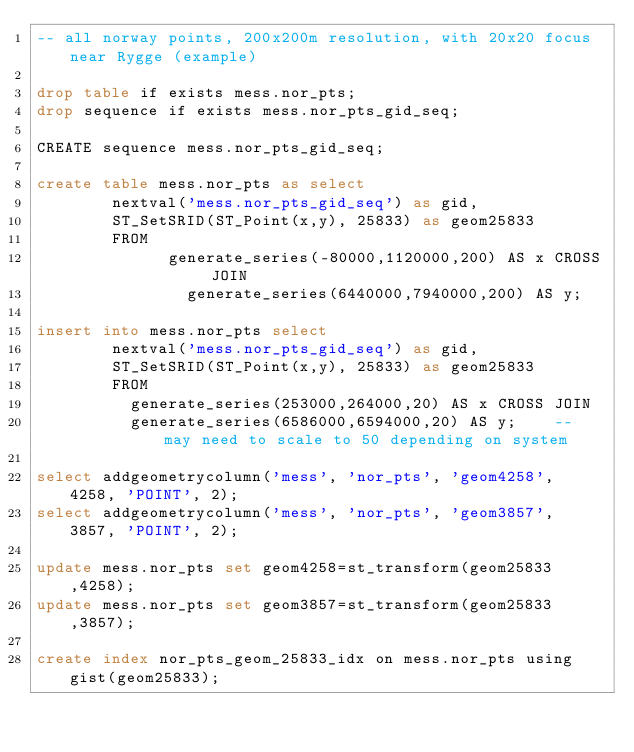<code> <loc_0><loc_0><loc_500><loc_500><_SQL_>-- all norway points, 200x200m resolution, with 20x20 focus near Rygge (example)

drop table if exists mess.nor_pts;
drop sequence if exists mess.nor_pts_gid_seq;

CREATE sequence mess.nor_pts_gid_seq;

create table mess.nor_pts as select 
        nextval('mess.nor_pts_gid_seq') as gid,
        ST_SetSRID(ST_Point(x,y), 25833) as geom25833
        FROM
            	generate_series(-80000,1120000,200) AS x CROSS JOIN
                generate_series(6440000,7940000,200) AS y;   

insert into mess.nor_pts select 
        nextval('mess.nor_pts_gid_seq') as gid,
        ST_SetSRID(ST_Point(x,y), 25833) as geom25833
        FROM
          generate_series(253000,264000,20) AS x CROSS JOIN
          generate_series(6586000,6594000,20) AS y;    -- may need to scale to 50 depending on system

select addgeometrycolumn('mess', 'nor_pts', 'geom4258', 4258, 'POINT', 2);
select addgeometrycolumn('mess', 'nor_pts', 'geom3857', 3857, 'POINT', 2);

update mess.nor_pts set geom4258=st_transform(geom25833,4258);
update mess.nor_pts set geom3857=st_transform(geom25833,3857);

create index nor_pts_geom_25833_idx on mess.nor_pts using gist(geom25833);</code> 